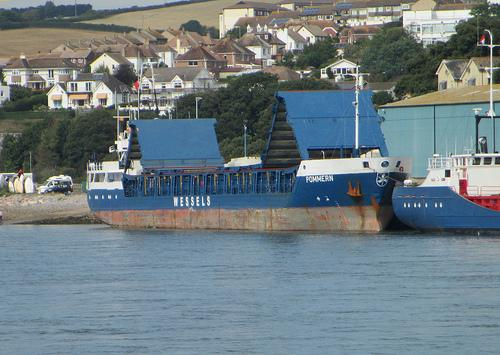Briefly describe the area where the trees are located in the image. The trees are situated between the water and houses, separating them, and they are green in color. Write a sentence about the colors in the image. The image has blue water, green trees, and several colorful elements, such as ships, cars, and buildings. Provide a brief description of the buildings present in the picture. There are houses and apartments with brown and grey roofs, a building with solar panels, and a building with sky light. Discuss the solar panel and its location in the picture. There is a solar panel on the roof of a building, which appears to be an eco-friendly feature. Describe the primary maritime vehicles in the photograph. A large blue cargo ship pulls a smaller boat, both on the water, with the name "Wessels" written on the side. Point out the features of the large blue cargo ship. The cargo ship has "Wessels" written on its side, a white pole, a rusted bottom, and it's pulling a smaller boat. Describe the visual style of the writing on the ship. The writing "Wessels" on the ship is in white color, featuring the letters 'w' and 'l' prominently. Describe the surroundings of the houses and apartments in the image. The houses and apartments are near green trees, with water and a hill in the background, and parked cars nearby. What are the parked vehicles in the image and their colors? There is a black sedan and a white van parked on land. Mention the main elements present in the image. There are ships, boats, houses, buildings, trees, water, and parked cars in the image. 